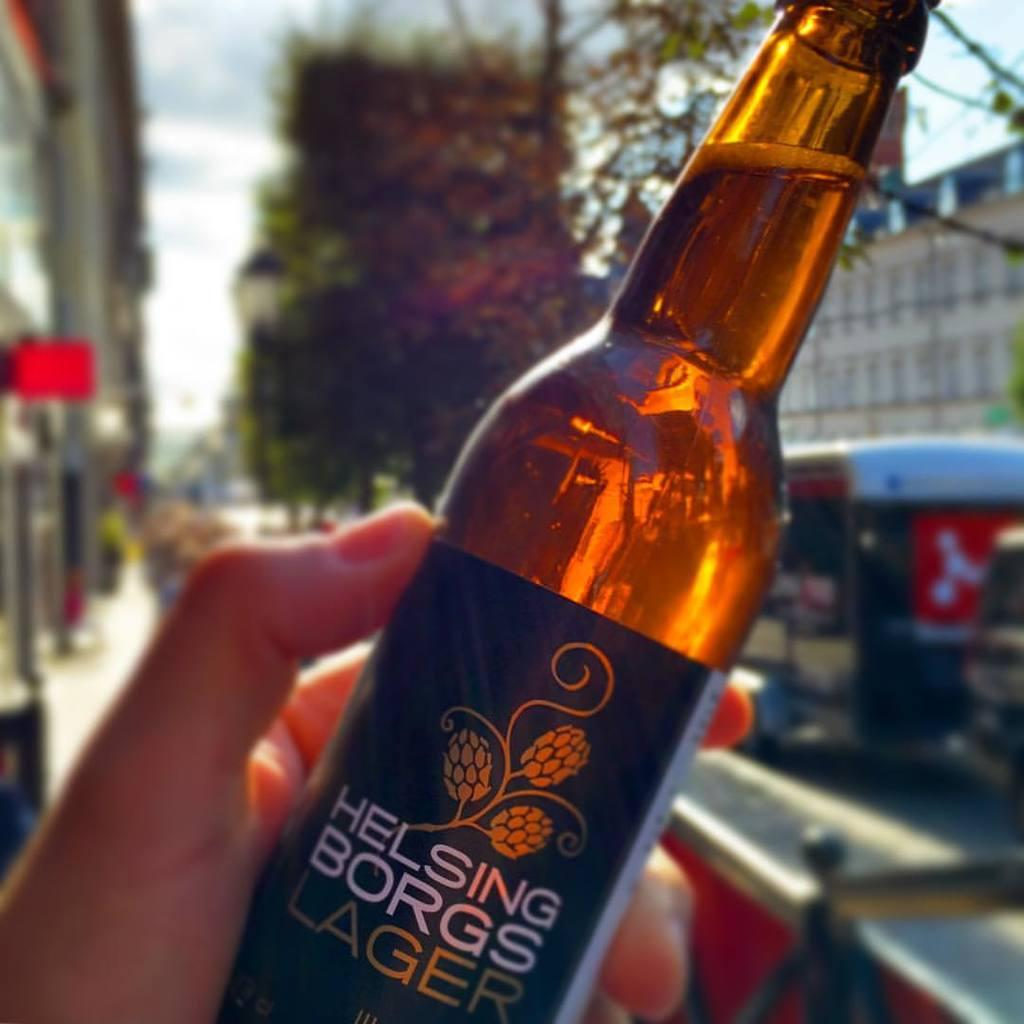What is being held by the person's hand in the image? There is a person's hand holding a bottle in the image. What can be seen in the distance behind the person? There are trees and buildings in the background of the image. What type of dinosaur can be seen walking in the background of the image? There are no dinosaurs present in the image; it features trees and buildings in the background. 